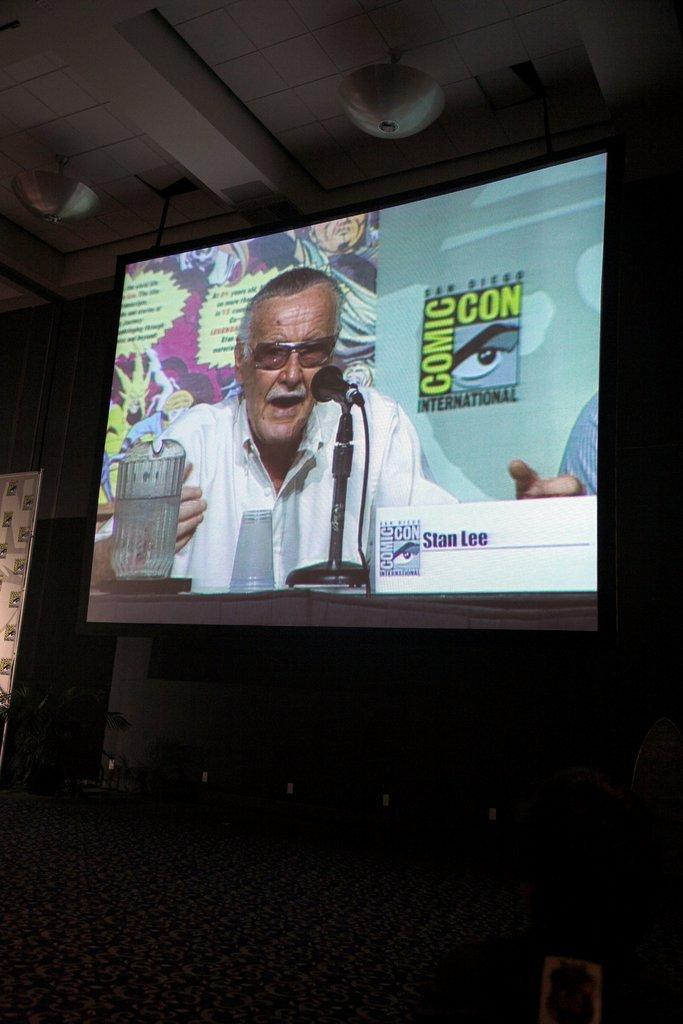<image>
Create a compact narrative representing the image presented. A projector screen showing an image of stan lee at new york comic con. 